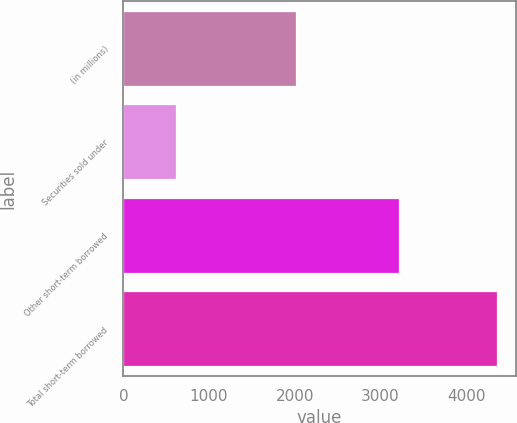Convert chart. <chart><loc_0><loc_0><loc_500><loc_500><bar_chart><fcel>(in millions)<fcel>Securities sold under<fcel>Other short-term borrowed<fcel>Total short-term borrowed<nl><fcel>2016<fcel>615<fcel>3211<fcel>4359<nl></chart> 